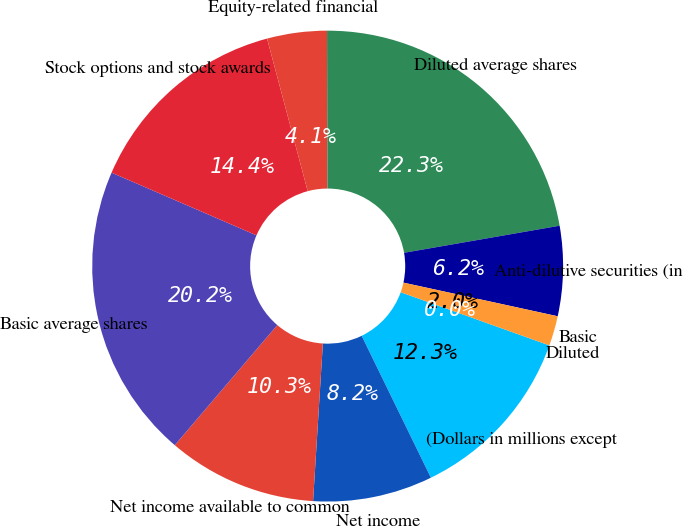<chart> <loc_0><loc_0><loc_500><loc_500><pie_chart><fcel>(Dollars in millions except<fcel>Net income<fcel>Net income available to common<fcel>Basic average shares<fcel>Stock options and stock awards<fcel>Equity-related financial<fcel>Diluted average shares<fcel>Anti-dilutive securities (in<fcel>Basic<fcel>Diluted<nl><fcel>12.31%<fcel>8.21%<fcel>10.26%<fcel>20.25%<fcel>14.36%<fcel>4.1%<fcel>22.3%<fcel>6.16%<fcel>2.05%<fcel>0.0%<nl></chart> 